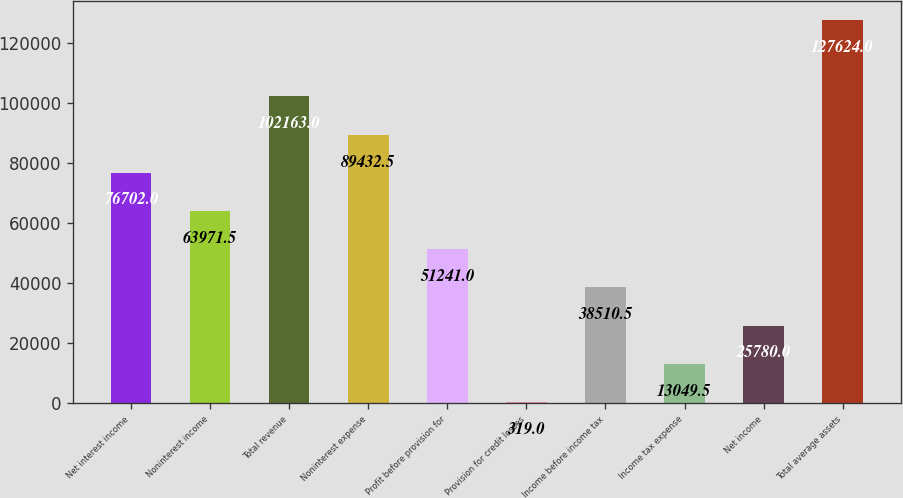<chart> <loc_0><loc_0><loc_500><loc_500><bar_chart><fcel>Net interest income<fcel>Noninterest income<fcel>Total revenue<fcel>Noninterest expense<fcel>Profit before provision for<fcel>Provision for credit losses<fcel>Income before income tax<fcel>Income tax expense<fcel>Net income<fcel>Total average assets<nl><fcel>76702<fcel>63971.5<fcel>102163<fcel>89432.5<fcel>51241<fcel>319<fcel>38510.5<fcel>13049.5<fcel>25780<fcel>127624<nl></chart> 